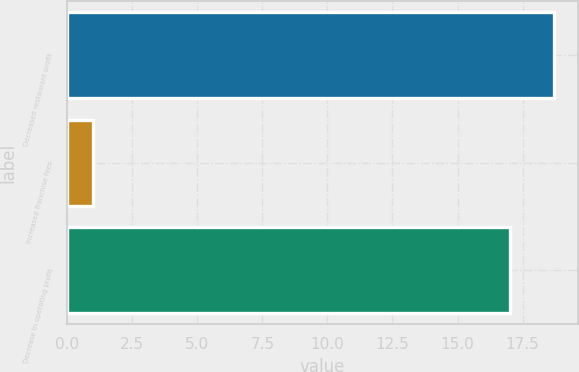<chart> <loc_0><loc_0><loc_500><loc_500><bar_chart><fcel>Decreased restaurant profit<fcel>Increased franchise fees<fcel>Decrease in operating profit<nl><fcel>18.7<fcel>1<fcel>17<nl></chart> 